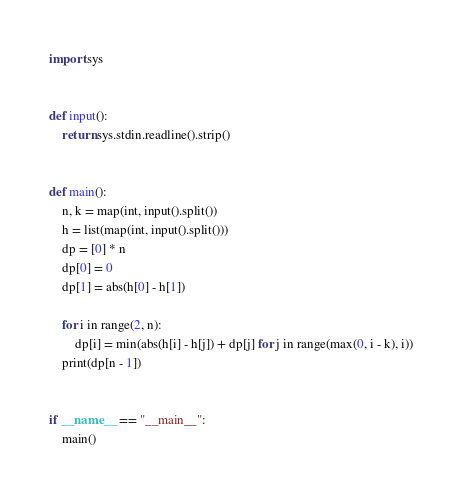<code> <loc_0><loc_0><loc_500><loc_500><_Python_>import sys


def input():
    return sys.stdin.readline().strip()


def main():
    n, k = map(int, input().split())
    h = list(map(int, input().split()))
    dp = [0] * n
    dp[0] = 0
    dp[1] = abs(h[0] - h[1])

    for i in range(2, n):
        dp[i] = min(abs(h[i] - h[j]) + dp[j] for j in range(max(0, i - k), i))
    print(dp[n - 1])


if __name__ == "__main__":
    main()</code> 